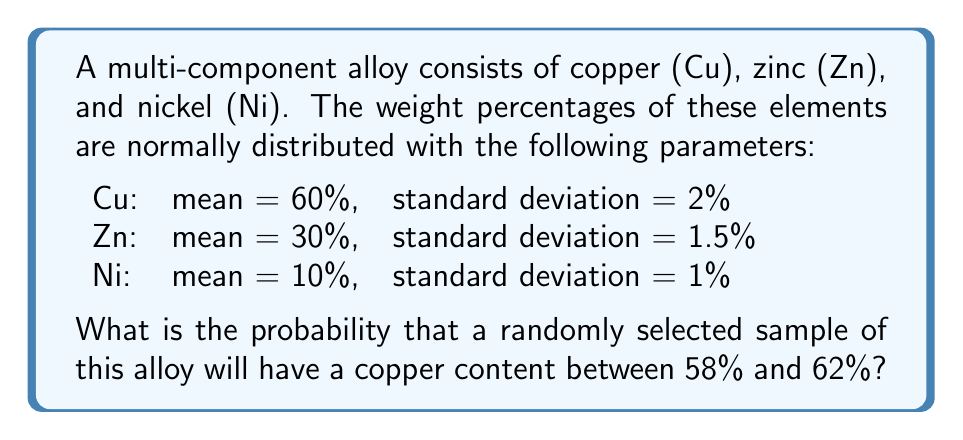Help me with this question. To solve this problem, we'll follow these steps:

1) First, recall that for a normal distribution, we can calculate the probability using the z-score and the standard normal distribution table.

2) The z-score is calculated using the formula:

   $$z = \frac{x - \mu}{\sigma}$$

   where $x$ is the value, $\mu$ is the mean, and $\sigma$ is the standard deviation.

3) For copper content between 58% and 62%, we need to calculate two z-scores:

   For 58%: $$z_1 = \frac{58 - 60}{2} = -1$$
   For 62%: $$z_2 = \frac{62 - 60}{2} = 1$$

4) Now, we need to find the area under the standard normal curve between these two z-scores. This can be done by finding the area from the center to each z-score and subtracting:

   $$P(-1 < Z < 1) = P(Z < 1) - P(Z < -1)$$

5) Using a standard normal distribution table:

   $P(Z < 1) = 0.8413$
   $P(Z < -1) = 1 - P(Z < 1) = 1 - 0.8413 = 0.1587$

6) Therefore, the probability is:

   $$0.8413 - 0.1587 = 0.6826$$

This means there's a 68.26% chance that a randomly selected sample will have a copper content between 58% and 62%.
Answer: 0.6826 or 68.26% 